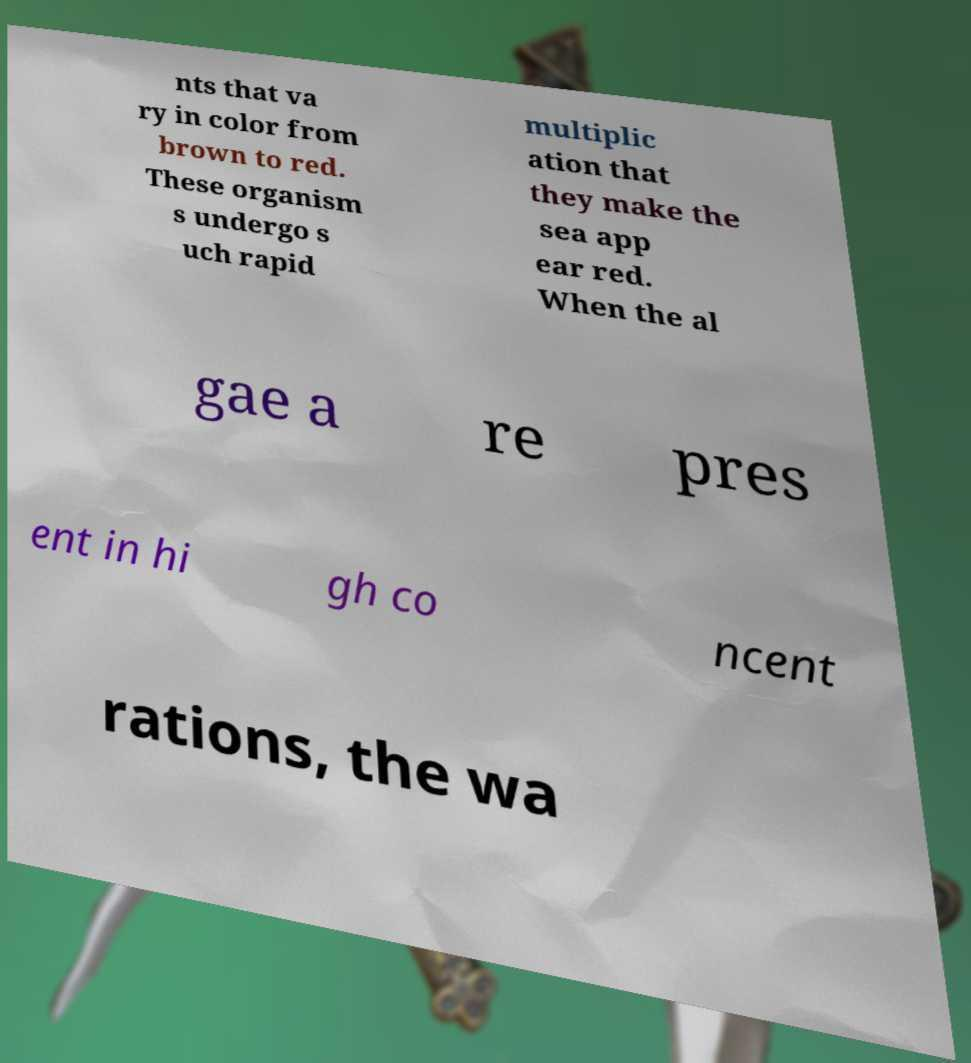I need the written content from this picture converted into text. Can you do that? nts that va ry in color from brown to red. These organism s undergo s uch rapid multiplic ation that they make the sea app ear red. When the al gae a re pres ent in hi gh co ncent rations, the wa 